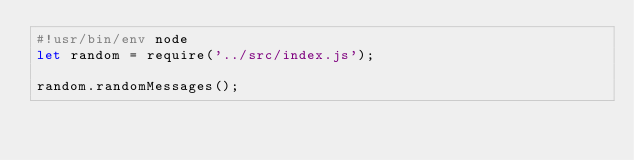<code> <loc_0><loc_0><loc_500><loc_500><_JavaScript_>#!usr/bin/env node
let random = require('../src/index.js');

random.randomMessages();</code> 